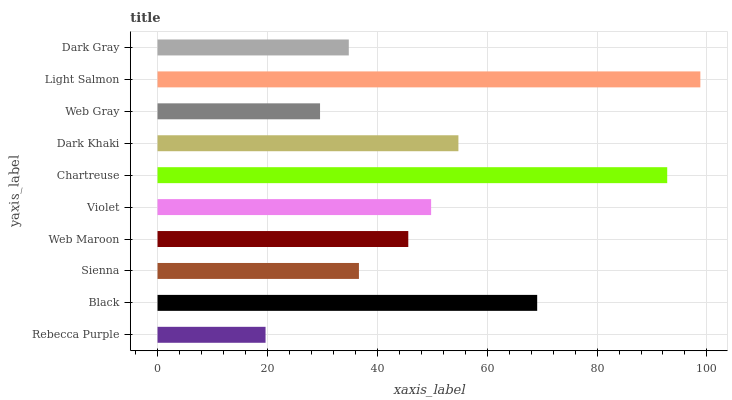Is Rebecca Purple the minimum?
Answer yes or no. Yes. Is Light Salmon the maximum?
Answer yes or no. Yes. Is Black the minimum?
Answer yes or no. No. Is Black the maximum?
Answer yes or no. No. Is Black greater than Rebecca Purple?
Answer yes or no. Yes. Is Rebecca Purple less than Black?
Answer yes or no. Yes. Is Rebecca Purple greater than Black?
Answer yes or no. No. Is Black less than Rebecca Purple?
Answer yes or no. No. Is Violet the high median?
Answer yes or no. Yes. Is Web Maroon the low median?
Answer yes or no. Yes. Is Black the high median?
Answer yes or no. No. Is Rebecca Purple the low median?
Answer yes or no. No. 